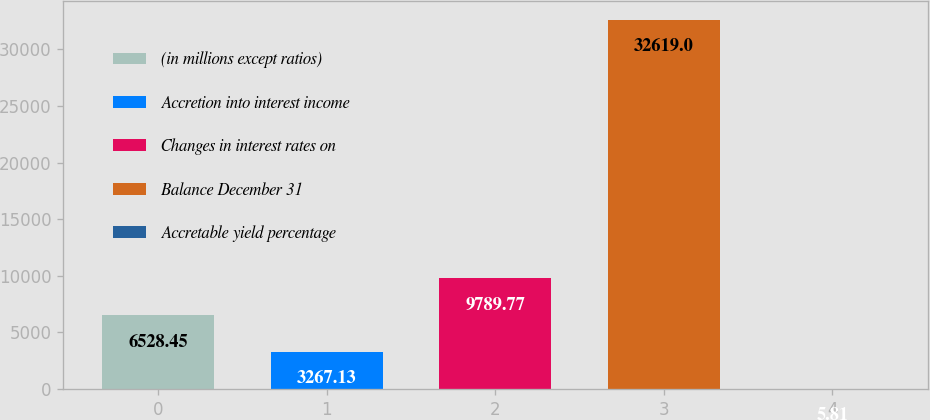Convert chart. <chart><loc_0><loc_0><loc_500><loc_500><bar_chart><fcel>(in millions except ratios)<fcel>Accretion into interest income<fcel>Changes in interest rates on<fcel>Balance December 31<fcel>Accretable yield percentage<nl><fcel>6528.45<fcel>3267.13<fcel>9789.77<fcel>32619<fcel>5.81<nl></chart> 